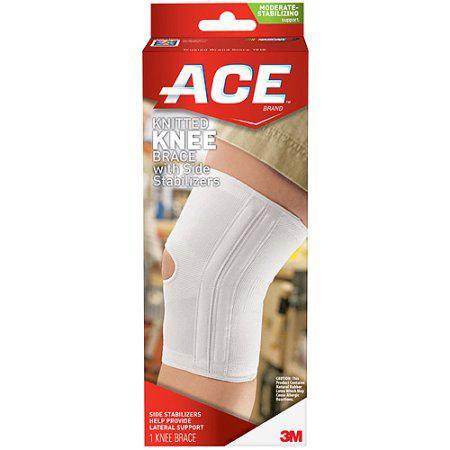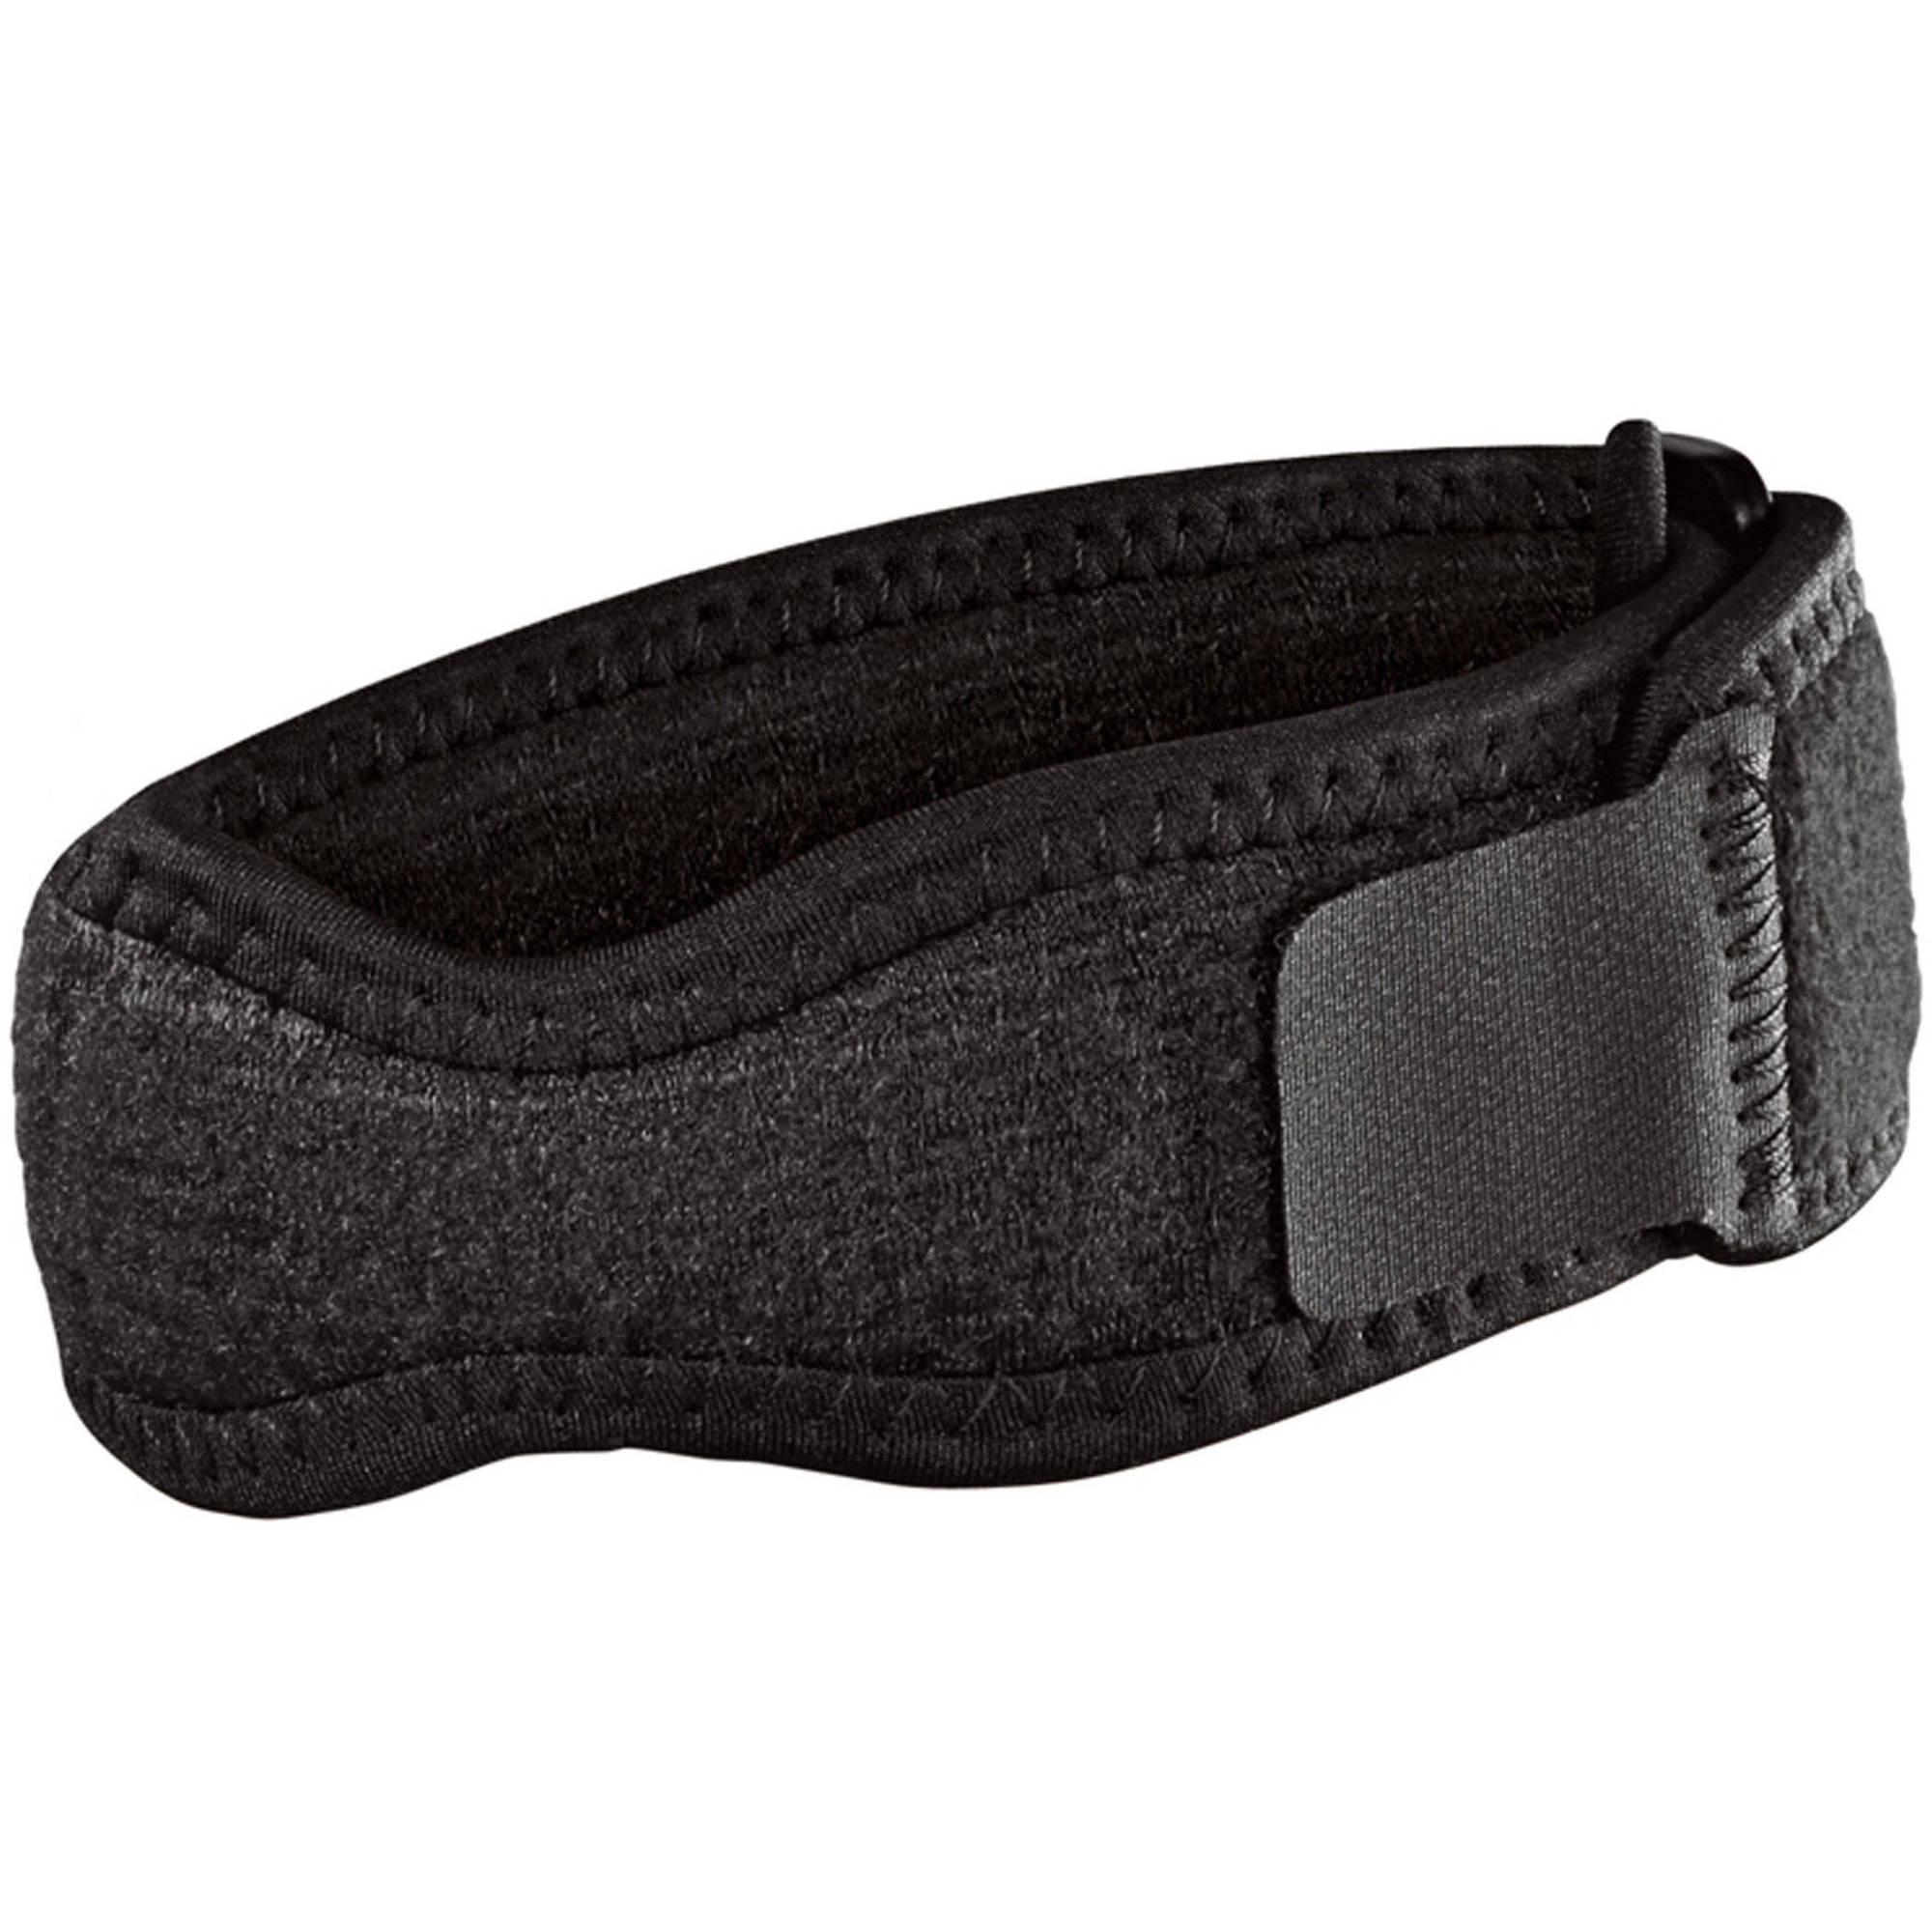The first image is the image on the left, the second image is the image on the right. For the images shown, is this caption "One image shows the knee brace package." true? Answer yes or no. Yes. 